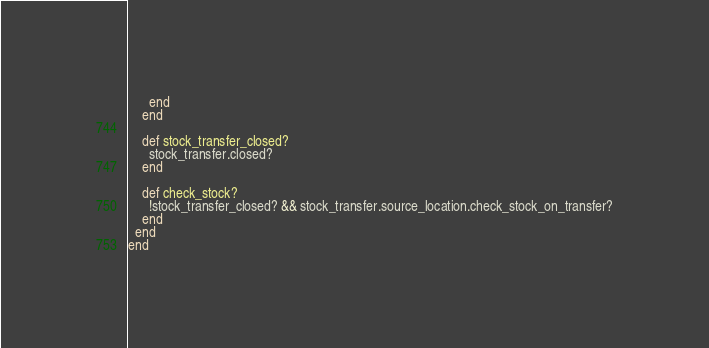<code> <loc_0><loc_0><loc_500><loc_500><_Ruby_>      end
    end

    def stock_transfer_closed?
      stock_transfer.closed?
    end

    def check_stock?
      !stock_transfer_closed? && stock_transfer.source_location.check_stock_on_transfer?
    end
  end
end
</code> 